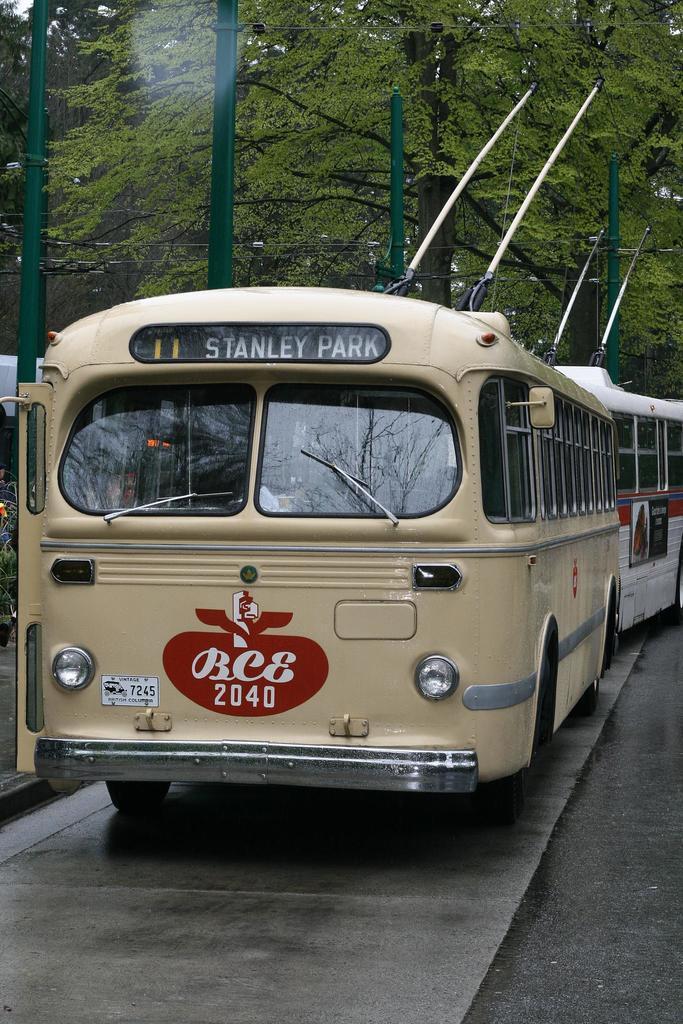Please provide a concise description of this image. In the center of the image, we can see buses and in the background, there are trees and poles along with wires. At the bottom, there is road. 